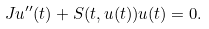Convert formula to latex. <formula><loc_0><loc_0><loc_500><loc_500>J u ^ { \prime \prime } ( t ) + S ( t , u ( t ) ) u ( t ) = 0 .</formula> 